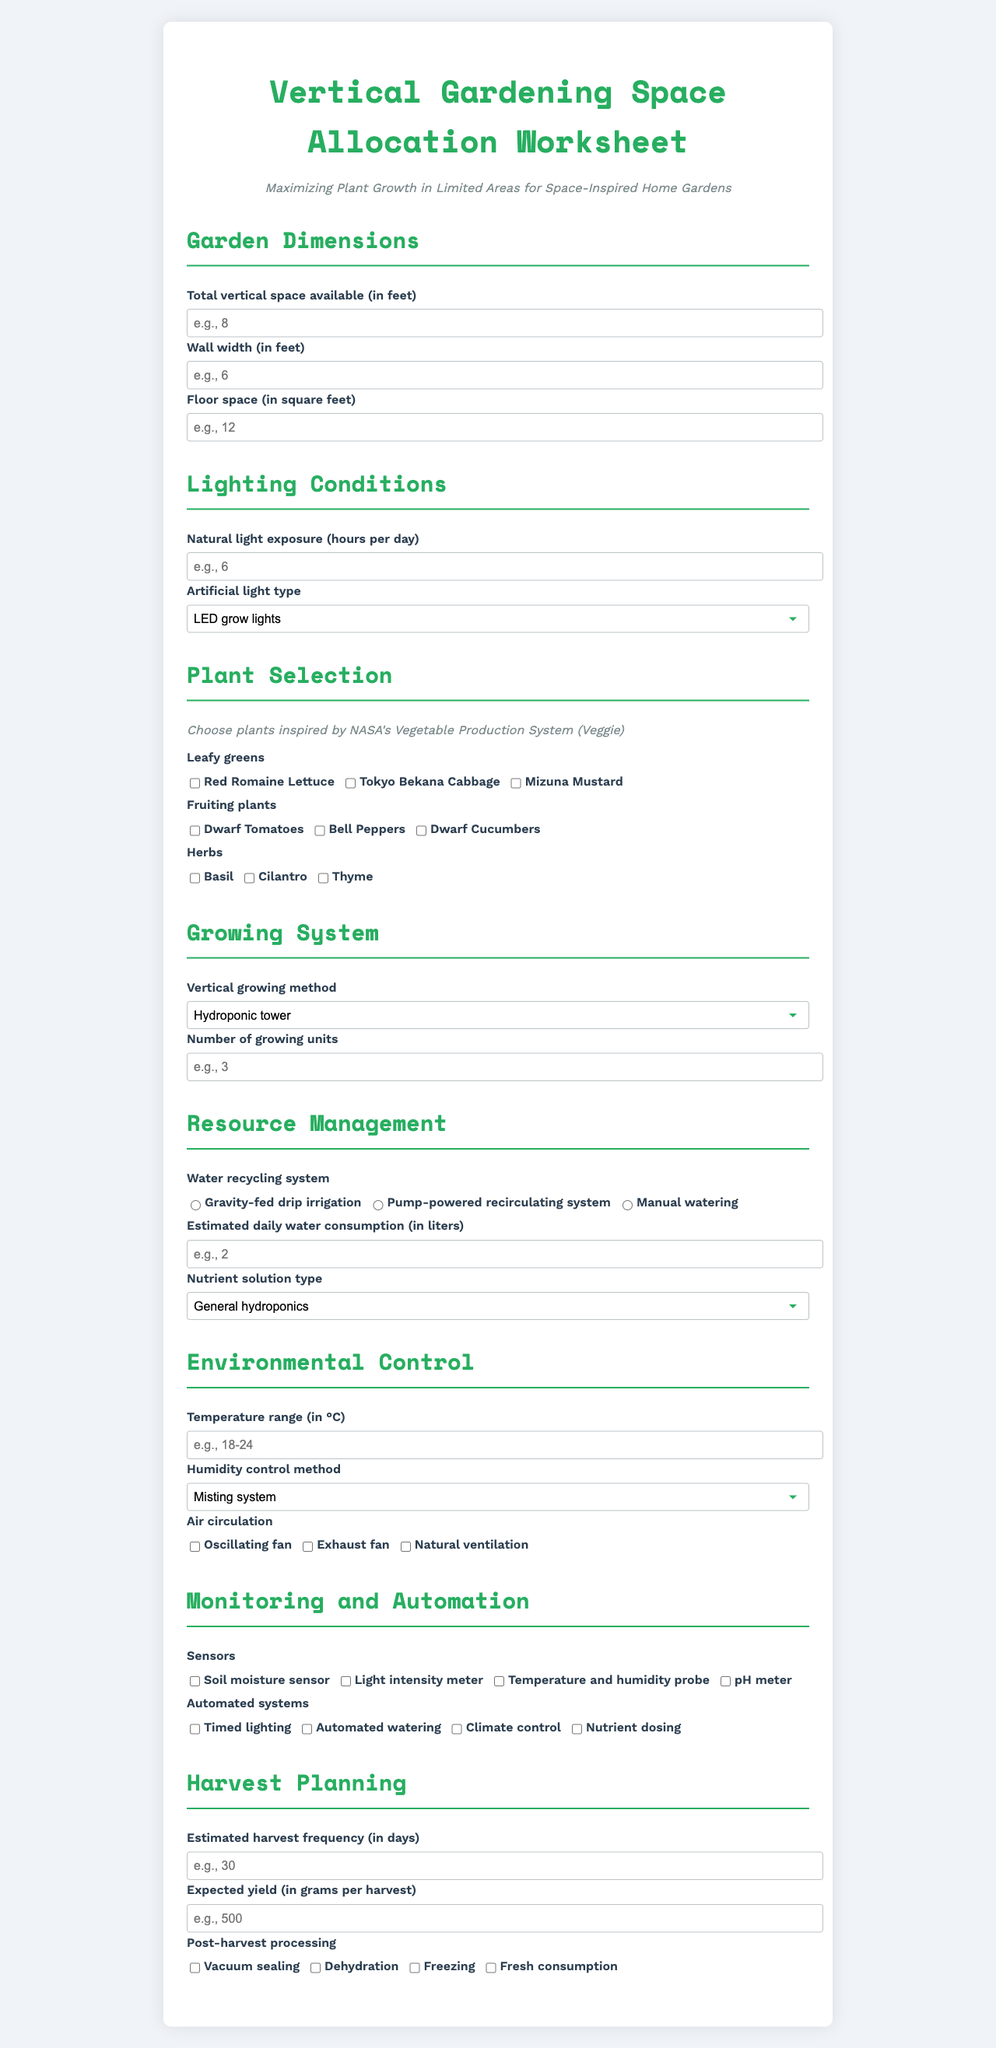what method of vertical growing is listed first? The vertical growing method is found in the "Growing System" section under the label "Vertical growing method." The first option is "Hydroponic tower."
Answer: Hydroponic tower what is the humidity control method listed? The humidity control method is a selection found in the "Environmental Control" section under the label "Humidity control method."
Answer: Misting system how many types of leafy greens can be selected? The number of options for leafy greens is found in the "Plant Selection" section, where there are three options to choose from.
Answer: 3 which nutrient solution type is recommended? The nutrient solution type is found in the "Resource Management" section under the label "Nutrient solution type."
Answer: Custom NASA-inspired blend what is the expected yield in grams per harvest? The expected yield can be found in the "Harvest Planning" section under the label "Expected yield (in grams per harvest)."
Answer: 500 what is the maximum number of plants that can be selected? The maximum number of plants is calculated by the sum of options available in the "Plant Selection" section (leafy greens, fruiting plants, herbs).
Answer: 9 what is the name of the worksheet? The name of the worksheet is clearly stated at the top of the document.
Answer: Vertical Gardening Space Allocation Worksheet 